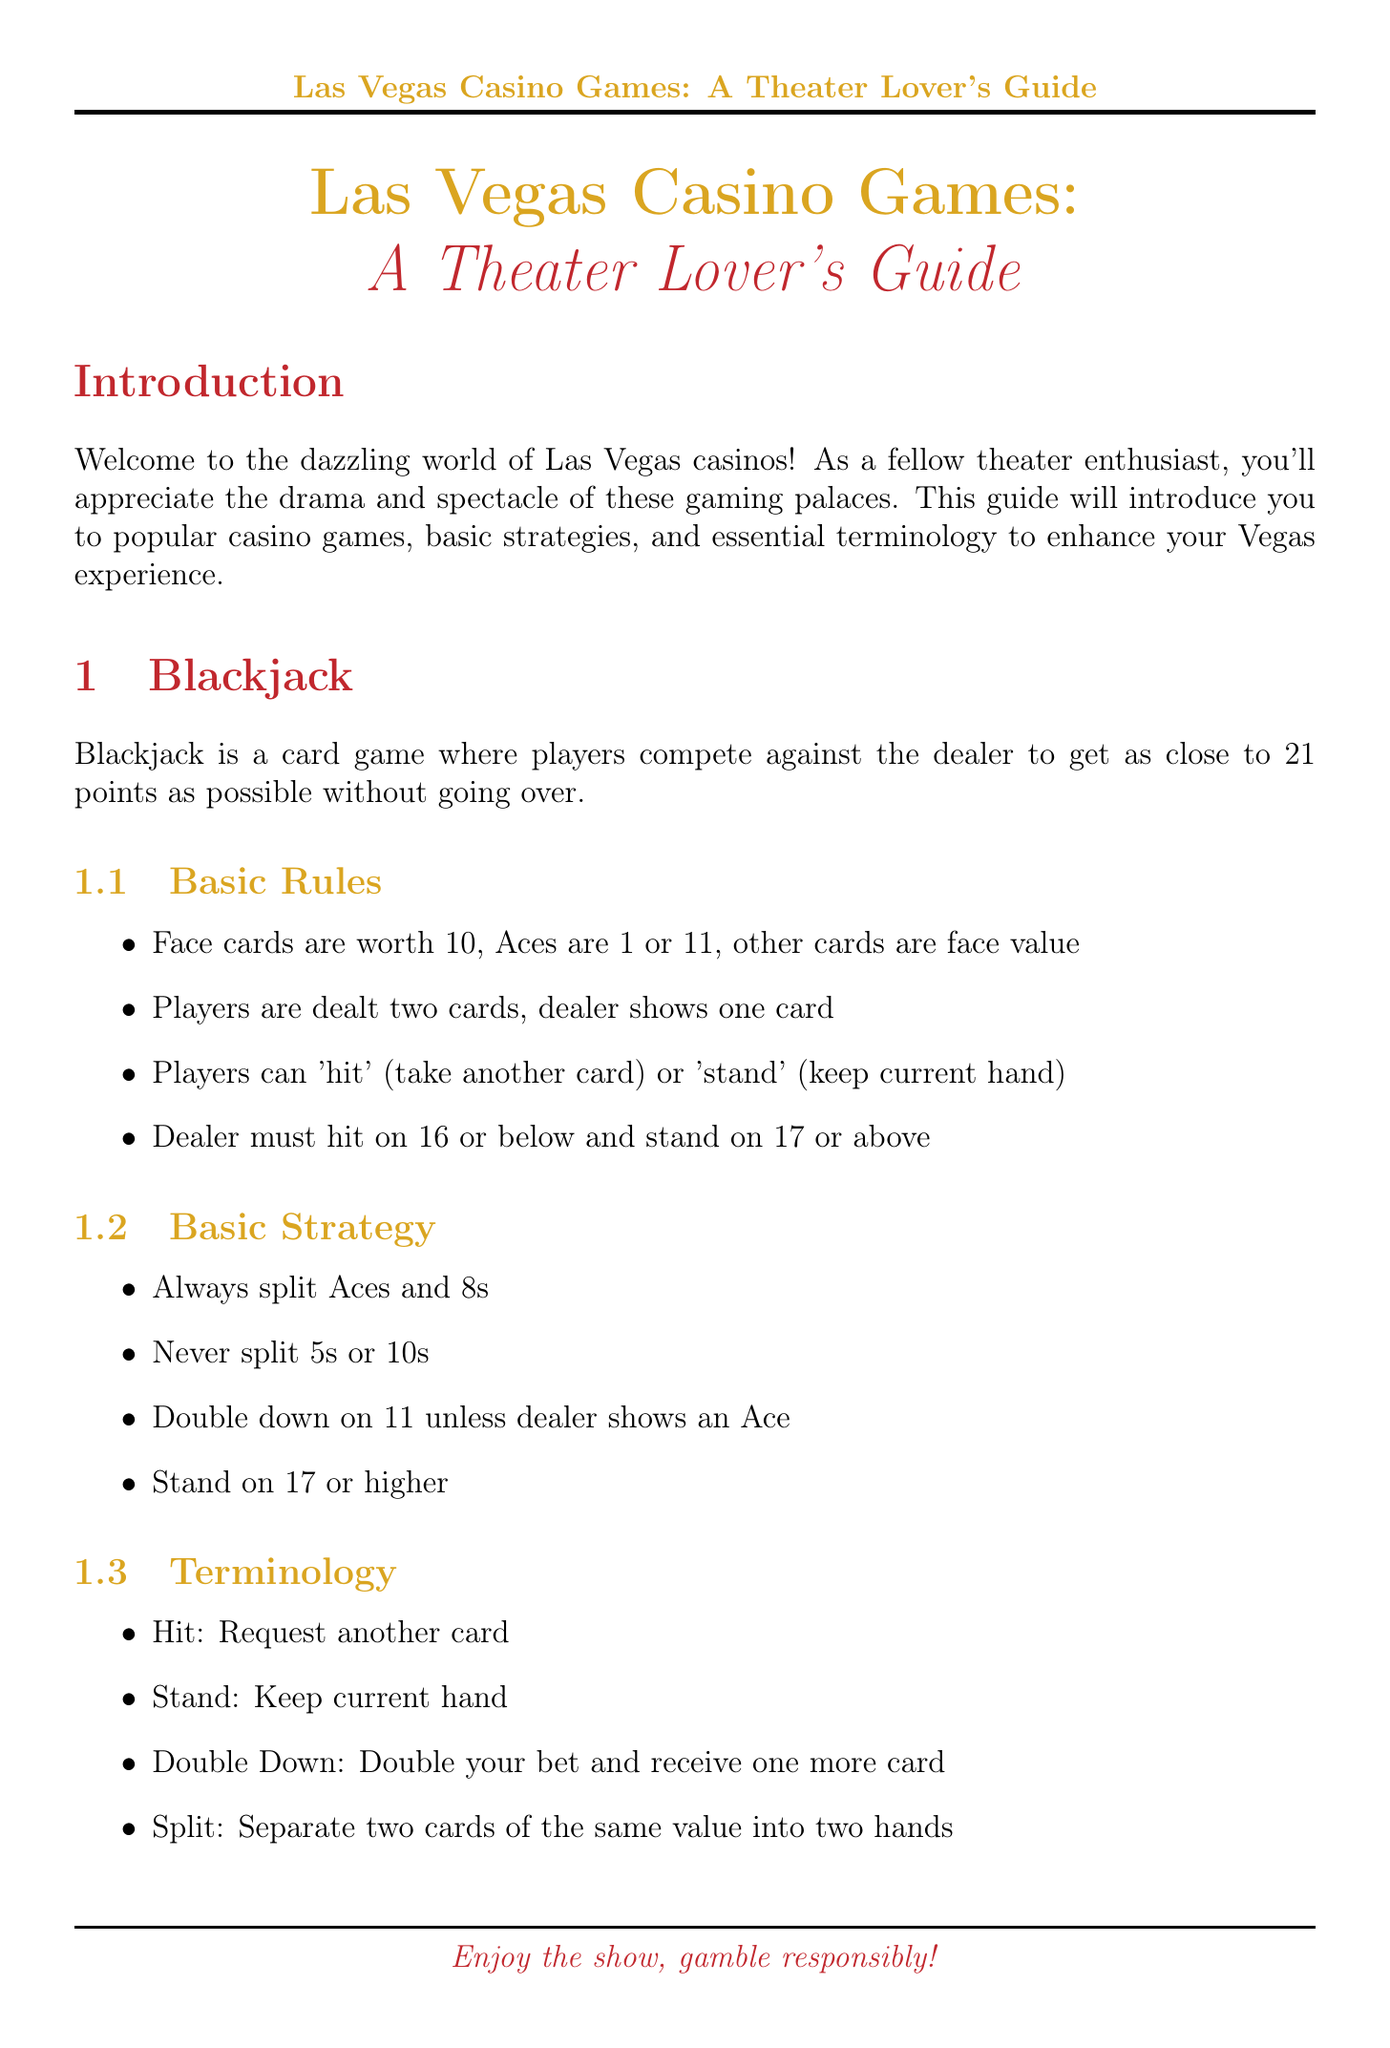what is the objective of blackjack? The objective is to get as close to 21 points as possible without going over.
Answer: close to 21 points name three popular blackjack venues in Las Vegas. The document lists popular venues where blackjack can be played, which are specifically mentioned.
Answer: Bellagio, Caesars Palace, Wynn Las Vegas what are the basic rules for Texas Hold'em? Basic rules outline how the game is played, including the dealing of cards and betting structure.
Answer: Players are dealt two private cards; five community cards are dealt in three stages; players bet after each stage; best five-card hand wins list two popular slot machine types. The document categorizes slot machines into different types, naming them specifically.
Answer: Traditional reel slots, Video slots what should a player do if they have a total of 17 or higher in blackjack? This is tied to the basic strategy outlined for blackjack, explaining how to play at that total.
Answer: Stand explain why position is important in poker. The document mentions an advantage related to player position but doesn't quantify it.
Answer: Later positions have an advantage what is a useful strategy for slot machines? The document offers tips for playing slot machines, highlighting effective practices for players.
Answer: Set a budget and stick to it what should you do when a dealer says "no more bets" at a blackjack table? This reflects general casino etiquette as mentioned in the document.
Answer: Don't touch your chips 